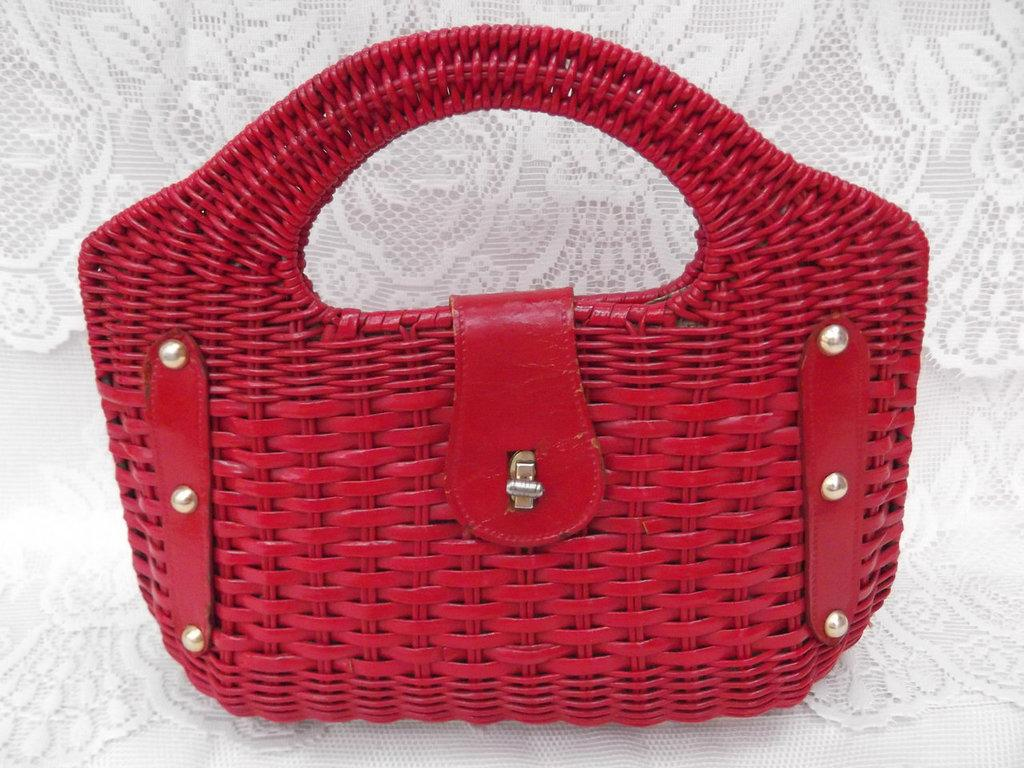What object is visible in the image? There is a handbag in the image. What is the handbag placed on? The handbag is kept on a cloth. What type of insurance policy is mentioned on the lace in the image? There is no mention of insurance or lace in the image; it only features a handbag placed on a cloth. 